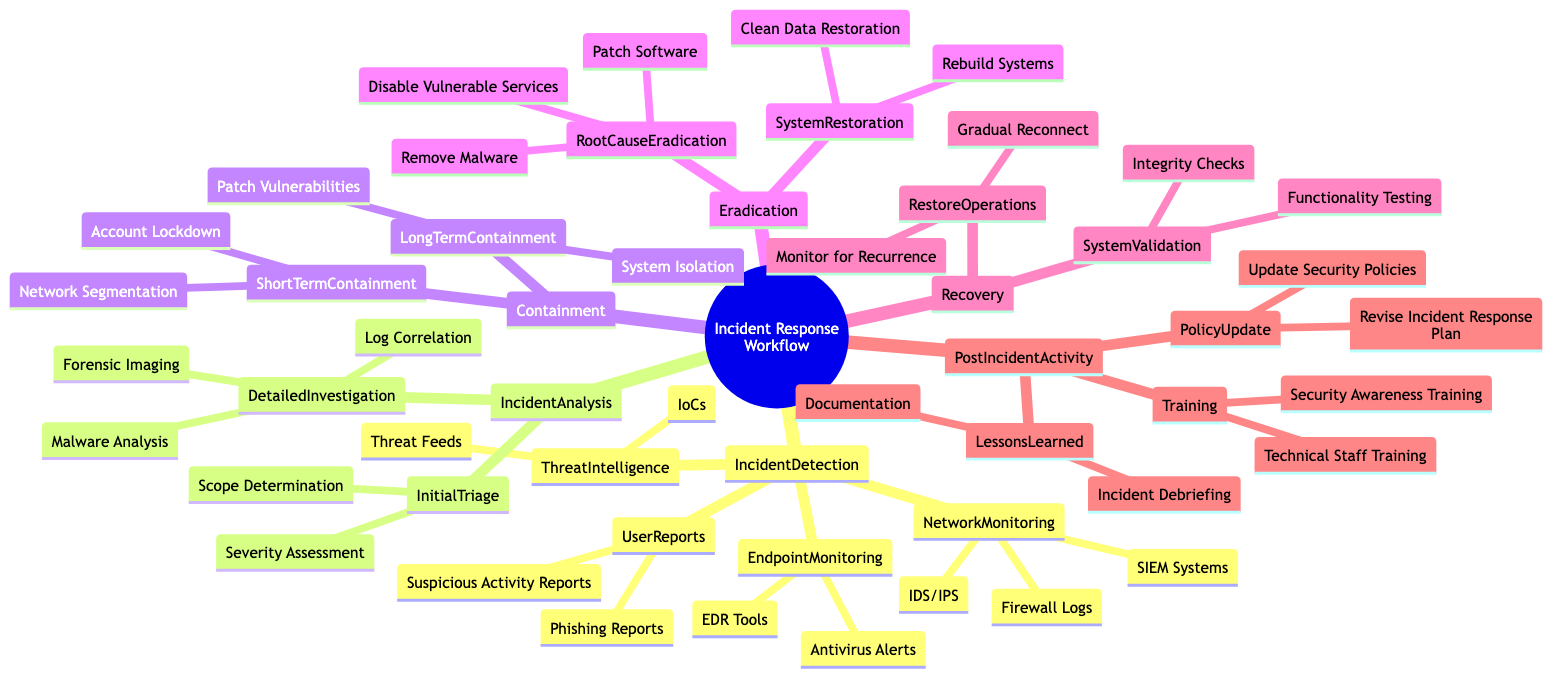What are the components of Incident Detection? The diagram outlines four main categories under Incident Detection: Network Monitoring, Endpoint Monitoring, User Reports, and Threat Intelligence. These categories include various specific tools and sources for detection.
Answer: Network Monitoring, Endpoint Monitoring, User Reports, Threat Intelligence How many nodes are present in the Containment category? The Containment category comprises two subcategories: Short Term Containment and Long Term Containment. Each of these has further specific actions. So there are two main nodes in this category.
Answer: 2 What is one action listed under Root Cause Eradication? The diagram shows three specific actions associated with Root Cause Eradication: Remove Malware, Patch Software, and Disable Vulnerable Services. One example of an action is “Remove Malware.”
Answer: Remove Malware Which response phase involves restoring operations? The Recovery phase explicitly includes the Restore Operations category which involves steps taken to reconnect systems post-incident. This indicates the phase where operations get restored.
Answer: Recovery Name a type of monitoring under Endpoint Monitoring. The Endpoint Monitoring category specifically lists EDR Tools and Antivirus Alerts as the types of monitoring. One example is "EDR Tools."
Answer: EDR Tools Which category includes lessons learned? The Post Incident Activity category covers reviews and enhancements that happen after an incident, specifically mentioning Lessons Learned, which focuses on understanding what occurred during the incident.
Answer: Post Incident Activity How many actions are under System Restoration? Under the Eradication phase, System Restoration has two specific actions: Rebuild Systems and Clean Data Restoration. Thus, there are two actions.
Answer: 2 What type of training is mentioned in the Post Incident Activity? The diagram indicates Training under Post Incident Activity, specifying two training types: Security Awareness Training and Technical Staff Training. A type mentioned is “Security Awareness Training.”
Answer: Security Awareness Training What does Initial Triage involve? The Initial Triage subcategory under the Incident Analysis phase includes both Severity Assessment and Scope Determination, indicating the components involved in initial assessment of an incident.
Answer: Severity Assessment, Scope Determination 